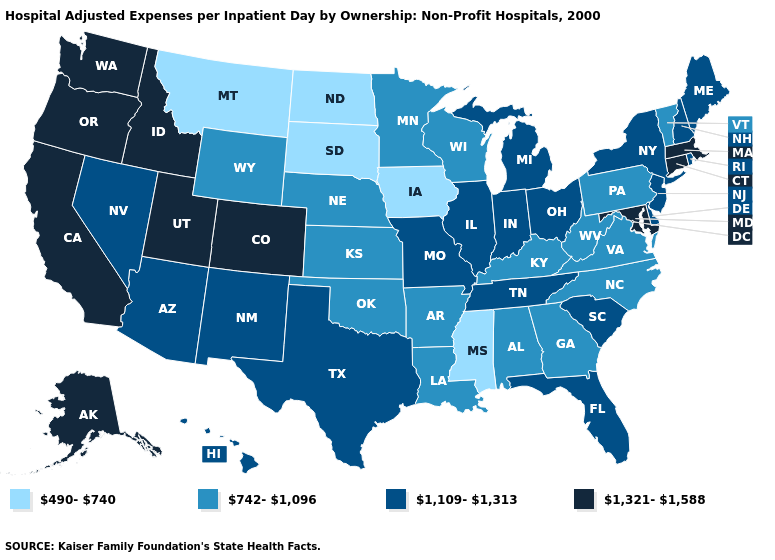What is the value of Indiana?
Keep it brief. 1,109-1,313. Does North Dakota have the highest value in the MidWest?
Answer briefly. No. Name the states that have a value in the range 1,109-1,313?
Write a very short answer. Arizona, Delaware, Florida, Hawaii, Illinois, Indiana, Maine, Michigan, Missouri, Nevada, New Hampshire, New Jersey, New Mexico, New York, Ohio, Rhode Island, South Carolina, Tennessee, Texas. What is the value of Oregon?
Concise answer only. 1,321-1,588. What is the value of Kentucky?
Keep it brief. 742-1,096. What is the value of Kansas?
Give a very brief answer. 742-1,096. Which states have the lowest value in the USA?
Short answer required. Iowa, Mississippi, Montana, North Dakota, South Dakota. What is the highest value in the MidWest ?
Concise answer only. 1,109-1,313. Does North Dakota have a lower value than New Mexico?
Concise answer only. Yes. What is the highest value in states that border North Carolina?
Concise answer only. 1,109-1,313. What is the value of Pennsylvania?
Keep it brief. 742-1,096. What is the lowest value in the USA?
Quick response, please. 490-740. Does Arizona have the lowest value in the West?
Give a very brief answer. No. Does Massachusetts have the highest value in the Northeast?
Write a very short answer. Yes. 